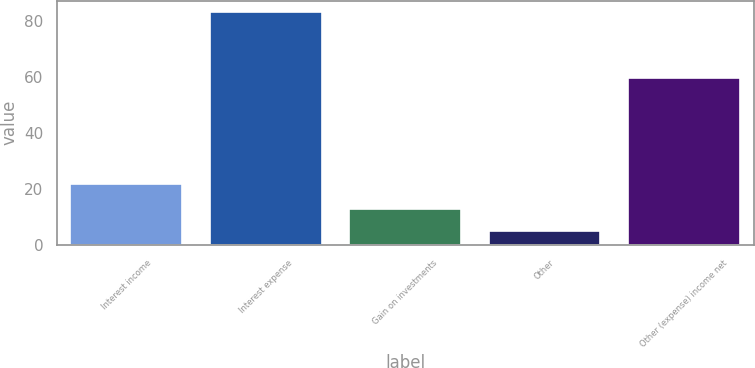Convert chart to OTSL. <chart><loc_0><loc_0><loc_500><loc_500><bar_chart><fcel>Interest income<fcel>Interest expense<fcel>Gain on investments<fcel>Other<fcel>Other (expense) income net<nl><fcel>21.8<fcel>83.3<fcel>12.92<fcel>5.1<fcel>59.8<nl></chart> 